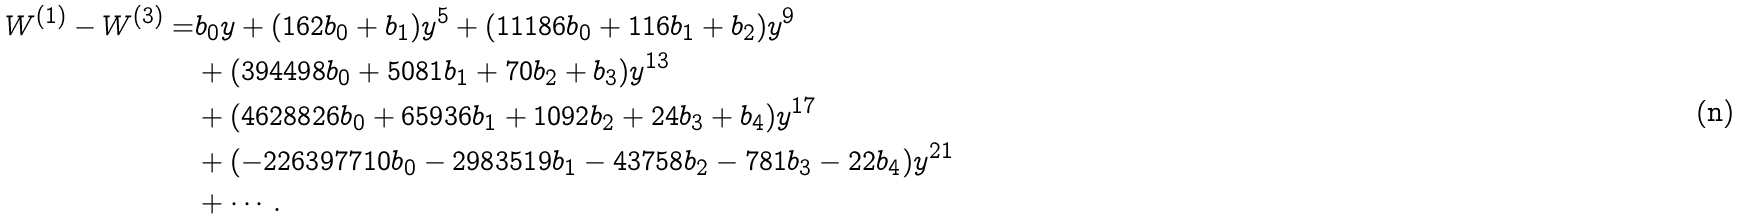<formula> <loc_0><loc_0><loc_500><loc_500>W ^ { ( 1 ) } - W ^ { ( 3 ) } = & b _ { 0 } y + ( 1 6 2 b _ { 0 } + b _ { 1 } ) y ^ { 5 } + ( 1 1 1 8 6 b _ { 0 } + 1 1 6 b _ { 1 } + b _ { 2 } ) y ^ { 9 } \\ & + ( 3 9 4 4 9 8 b _ { 0 } + 5 0 8 1 b _ { 1 } + 7 0 b _ { 2 } + b _ { 3 } ) y ^ { 1 3 } \\ & + ( 4 6 2 8 8 2 6 b _ { 0 } + 6 5 9 3 6 b _ { 1 } + 1 0 9 2 b _ { 2 } + 2 4 b _ { 3 } + b _ { 4 } ) y ^ { 1 7 } \\ & + ( - 2 2 6 3 9 7 7 1 0 b _ { 0 } - 2 9 8 3 5 1 9 b _ { 1 } - 4 3 7 5 8 b _ { 2 } - 7 8 1 b _ { 3 } - 2 2 b _ { 4 } ) y ^ { 2 1 } \\ & + \cdots .</formula> 